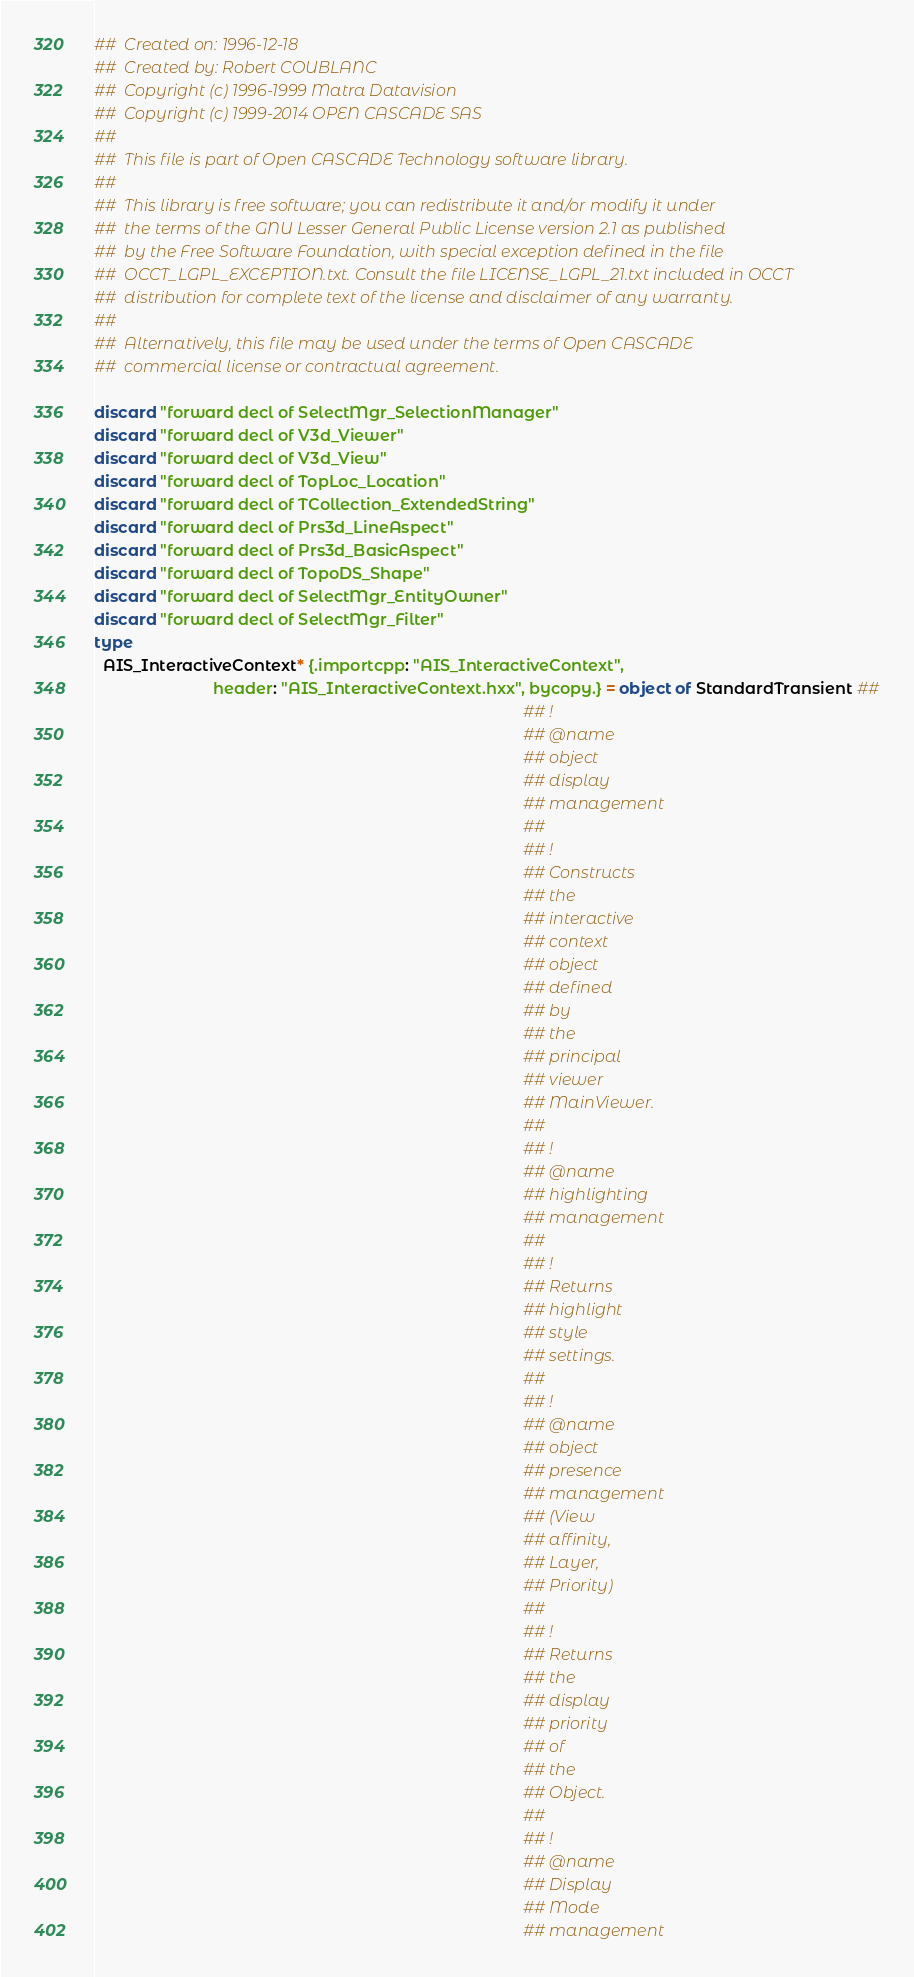Convert code to text. <code><loc_0><loc_0><loc_500><loc_500><_Nim_>##  Created on: 1996-12-18
##  Created by: Robert COUBLANC
##  Copyright (c) 1996-1999 Matra Datavision
##  Copyright (c) 1999-2014 OPEN CASCADE SAS
##
##  This file is part of Open CASCADE Technology software library.
##
##  This library is free software; you can redistribute it and/or modify it under
##  the terms of the GNU Lesser General Public License version 2.1 as published
##  by the Free Software Foundation, with special exception defined in the file
##  OCCT_LGPL_EXCEPTION.txt. Consult the file LICENSE_LGPL_21.txt included in OCCT
##  distribution for complete text of the license and disclaimer of any warranty.
##
##  Alternatively, this file may be used under the terms of Open CASCADE
##  commercial license or contractual agreement.

discard "forward decl of SelectMgr_SelectionManager"
discard "forward decl of V3d_Viewer"
discard "forward decl of V3d_View"
discard "forward decl of TopLoc_Location"
discard "forward decl of TCollection_ExtendedString"
discard "forward decl of Prs3d_LineAspect"
discard "forward decl of Prs3d_BasicAspect"
discard "forward decl of TopoDS_Shape"
discard "forward decl of SelectMgr_EntityOwner"
discard "forward decl of SelectMgr_Filter"
type
  AIS_InteractiveContext* {.importcpp: "AIS_InteractiveContext",
                           header: "AIS_InteractiveContext.hxx", bycopy.} = object of StandardTransient ##
                                                                                                 ## !
                                                                                                 ## @name
                                                                                                 ## object
                                                                                                 ## display
                                                                                                 ## management
                                                                                                 ##
                                                                                                 ## !
                                                                                                 ## Constructs
                                                                                                 ## the
                                                                                                 ## interactive
                                                                                                 ## context
                                                                                                 ## object
                                                                                                 ## defined
                                                                                                 ## by
                                                                                                 ## the
                                                                                                 ## principal
                                                                                                 ## viewer
                                                                                                 ## MainViewer.
                                                                                                 ##
                                                                                                 ## !
                                                                                                 ## @name
                                                                                                 ## highlighting
                                                                                                 ## management
                                                                                                 ##
                                                                                                 ## !
                                                                                                 ## Returns
                                                                                                 ## highlight
                                                                                                 ## style
                                                                                                 ## settings.
                                                                                                 ##
                                                                                                 ## !
                                                                                                 ## @name
                                                                                                 ## object
                                                                                                 ## presence
                                                                                                 ## management
                                                                                                 ## (View
                                                                                                 ## affinity,
                                                                                                 ## Layer,
                                                                                                 ## Priority)
                                                                                                 ##
                                                                                                 ## !
                                                                                                 ## Returns
                                                                                                 ## the
                                                                                                 ## display
                                                                                                 ## priority
                                                                                                 ## of
                                                                                                 ## the
                                                                                                 ## Object.
                                                                                                 ##
                                                                                                 ## !
                                                                                                 ## @name
                                                                                                 ## Display
                                                                                                 ## Mode
                                                                                                 ## management</code> 